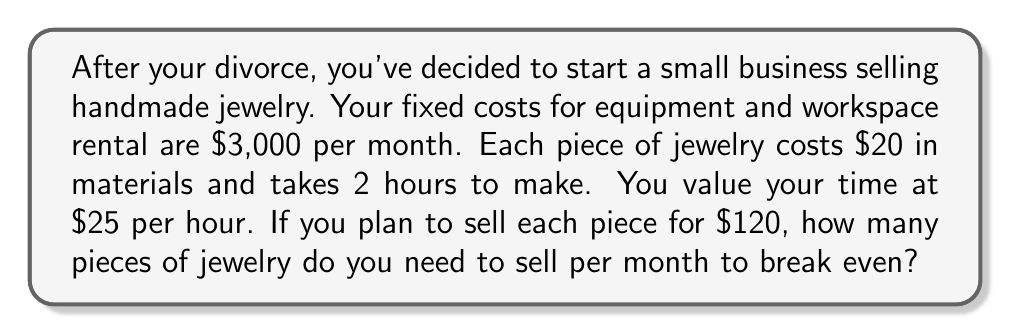Give your solution to this math problem. To calculate the break-even point, we need to determine the number of units (pieces of jewelry) that need to be sold for total revenue to equal total costs. Let's break this down step-by-step:

1. Define variables:
   Let $x$ = number of pieces sold per month

2. Calculate variable cost per unit:
   Material cost = $20
   Labor cost = 2 hours × $25/hour = $50
   Total variable cost per unit = $20 + $50 = $70

3. Set up the break-even equation:
   Total Revenue = Total Costs
   $120x = 3000 + 70x$

4. Solve for $x$:
   $$\begin{align}
   120x &= 3000 + 70x \\
   120x - 70x &= 3000 \\
   50x &= 3000 \\
   x &= \frac{3000}{50} \\
   x &= 60
   \end{align}$$

Therefore, you need to sell 60 pieces of jewelry per month to break even.

To verify:
Revenue: 60 × $120 = $7,200
Costs: $3,000 (fixed) + 60 × $70 (variable) = $7,200

Revenue equals costs, confirming the break-even point.
Answer: 60 pieces of jewelry per month 